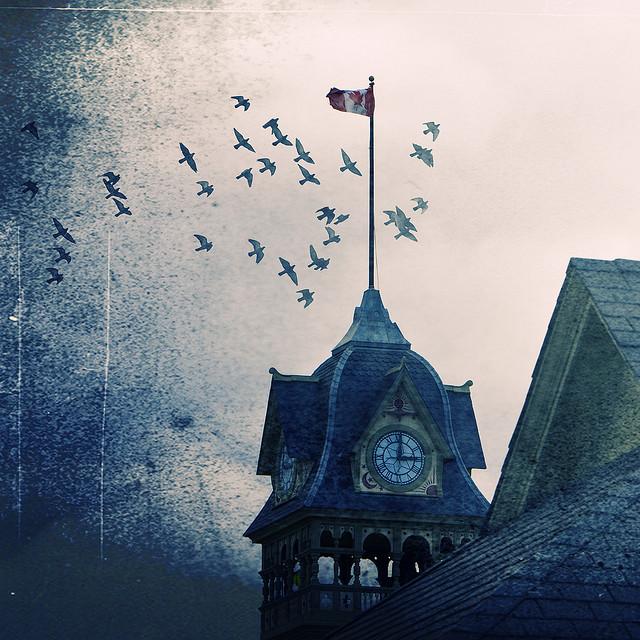How many flags are there?
Short answer required. 1. What is the object on top of the post?
Answer briefly. Flag. Is there a flag pole next to the church?
Concise answer only. Yes. Does the clock in the photo say the time is 4:45 or 4:46?
Keep it brief. Neither. Is the clock inside or out?
Short answer required. Out. What time is the church clock?
Quick response, please. 12:15. Why are the birds flying over this church?
Be succinct. Migrating. What time is it?
Quick response, please. 3:00. 